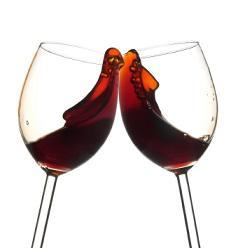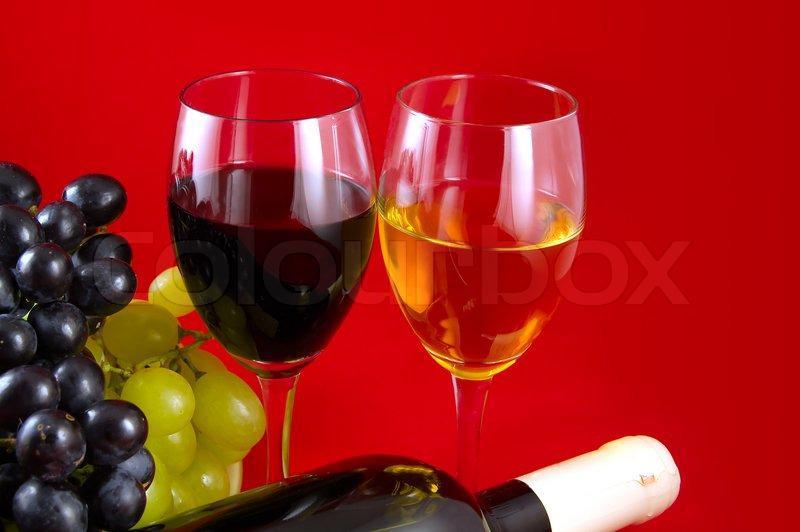The first image is the image on the left, the second image is the image on the right. Analyze the images presented: Is the assertion "The right image contains two wine glasses with red wine in them." valid? Answer yes or no. No. The first image is the image on the left, the second image is the image on the right. Evaluate the accuracy of this statement regarding the images: "A pair of clinking wine glasses create a splash of wine that reaches above the rim of the glass.". Is it true? Answer yes or no. Yes. 